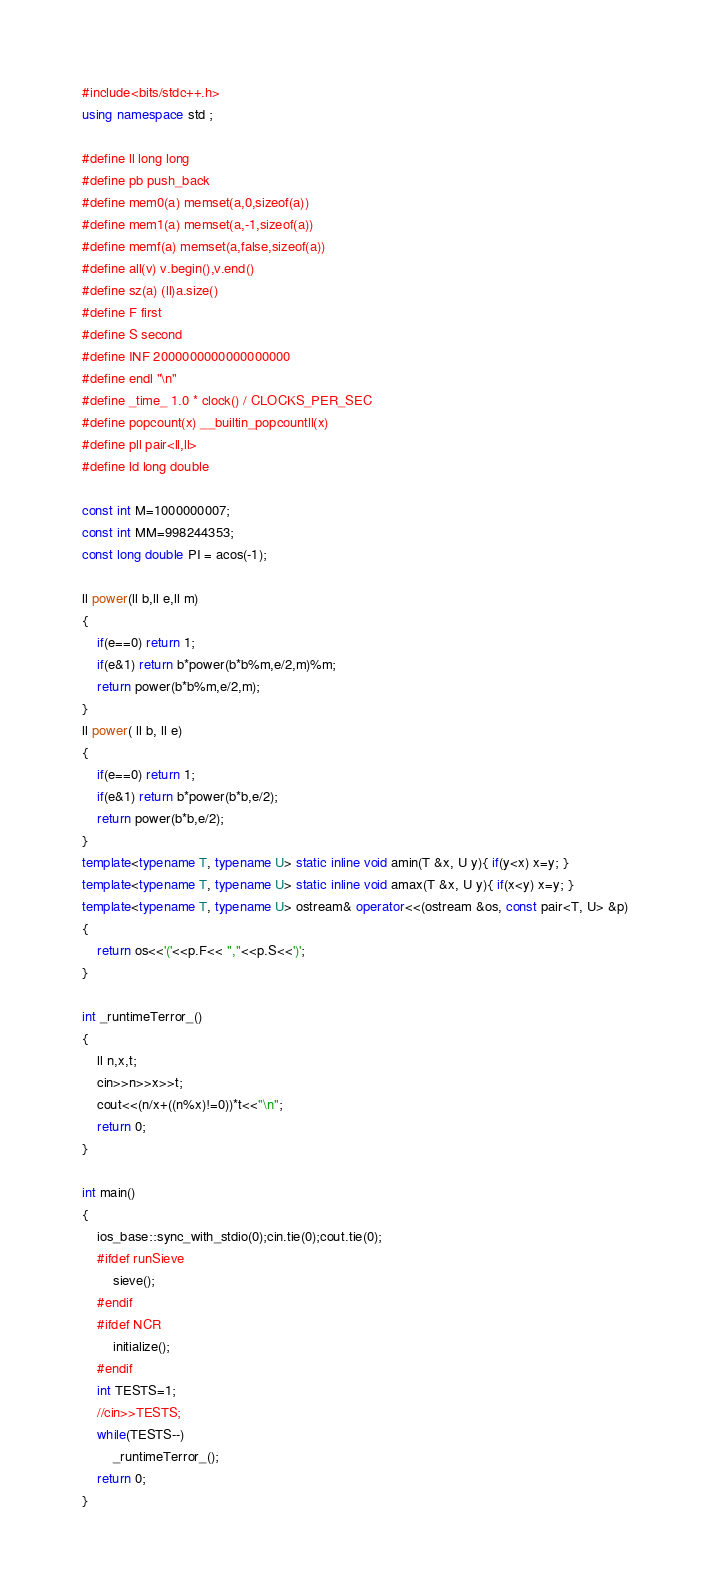<code> <loc_0><loc_0><loc_500><loc_500><_C++_>#include<bits/stdc++.h>
using namespace std ;

#define ll long long 
#define pb push_back
#define mem0(a) memset(a,0,sizeof(a))
#define mem1(a) memset(a,-1,sizeof(a))
#define memf(a) memset(a,false,sizeof(a))
#define all(v) v.begin(),v.end()
#define sz(a) (ll)a.size()
#define F first
#define S second
#define INF 2000000000000000000
#define endl "\n"
#define _time_ 1.0 * clock() / CLOCKS_PER_SEC
#define popcount(x) __builtin_popcountll(x)
#define pll pair<ll,ll> 
#define ld long double

const int M=1000000007;
const int MM=998244353;
const long double PI = acos(-1);

ll power(ll b,ll e,ll m)
{
    if(e==0) return 1;
    if(e&1) return b*power(b*b%m,e/2,m)%m;
    return power(b*b%m,e/2,m);
}
ll power( ll b, ll e)
{
    if(e==0) return 1;
    if(e&1) return b*power(b*b,e/2);
    return power(b*b,e/2);
}
template<typename T, typename U> static inline void amin(T &x, U y){ if(y<x) x=y; }
template<typename T, typename U> static inline void amax(T &x, U y){ if(x<y) x=y; }
template<typename T, typename U> ostream& operator<<(ostream &os, const pair<T, U> &p)
{ 
    return os<<'('<<p.F<< ","<<p.S<<')'; 
}

int _runtimeTerror_()
{
    ll n,x,t;
    cin>>n>>x>>t;
    cout<<(n/x+((n%x)!=0))*t<<"\n";
    return 0;
}

int main()
{
    ios_base::sync_with_stdio(0);cin.tie(0);cout.tie(0);
    #ifdef runSieve
        sieve();
    #endif
    #ifdef NCR
        initialize();
    #endif
    int TESTS=1;
    //cin>>TESTS;
    while(TESTS--)
        _runtimeTerror_();
    return 0;
}</code> 